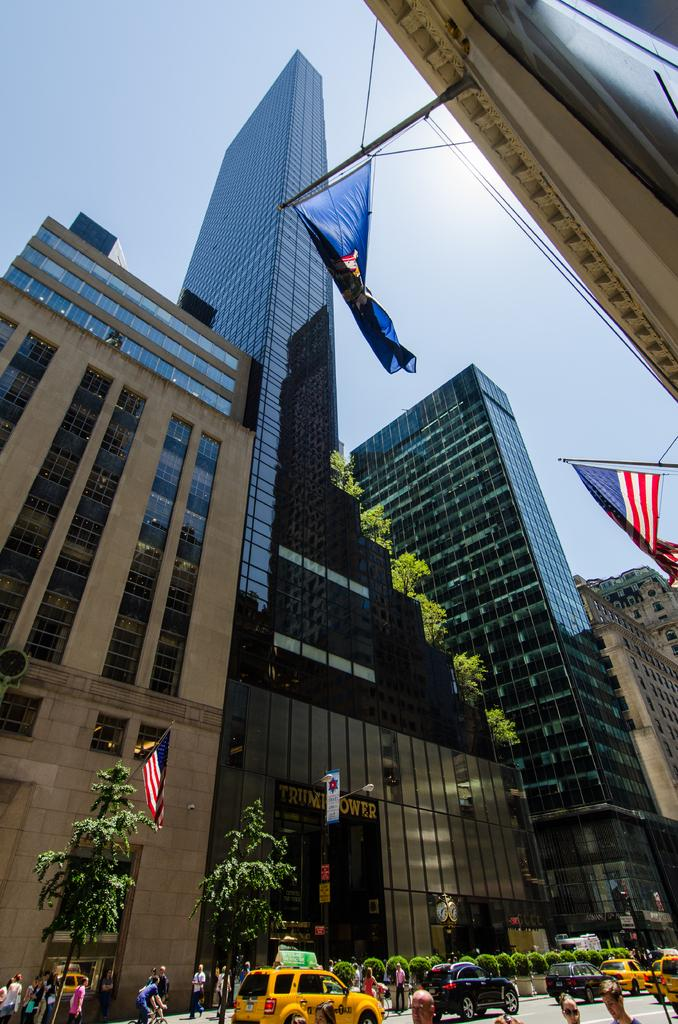Who or what can be seen in the image? There are people in the image. What else is present in the image besides people? There are cars, plants, trees, and buildings in the image. Can you describe the background of the image? In the background of the image, there are flags and a clear sky visible. How many flags are present in the background? There are four flags in the background of the image. What type of wool is being used to make the holiday turkey in the image? There is no wool or holiday turkey present in the image. 